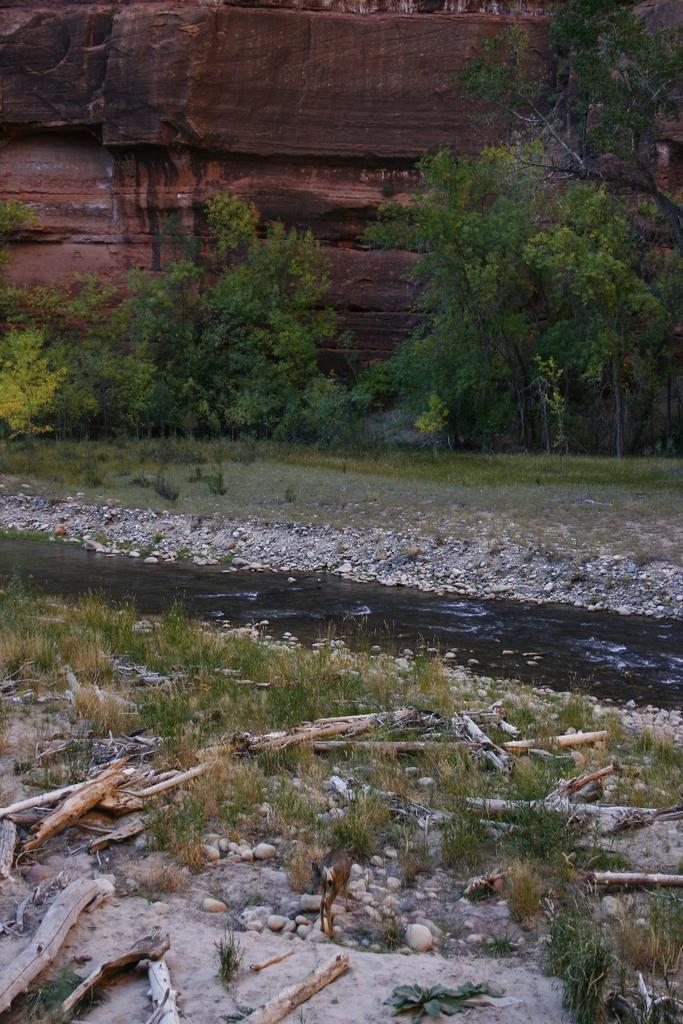What type of natural formation is visible in the image? There is a mountain in the image. What type of vegetation can be seen in the image? There are trees in the image. What body of water is present in the image? There is a canal at the bottom of the image. What else can be found on the ground in the image? There are objects on the ground in the image. What type of lace can be seen on the mountain in the image? There is no lace present on the mountain in the image. What type of cream is being used to paint the trees in the image? There is no cream being used to paint the trees in the image; the trees are natural vegetation. 